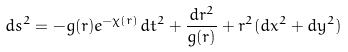Convert formula to latex. <formula><loc_0><loc_0><loc_500><loc_500>d s ^ { 2 } = - g ( r ) e ^ { - \chi ( r ) } d t ^ { 2 } + \frac { d r ^ { 2 } } { g ( r ) } + r ^ { 2 } ( d x ^ { 2 } + d y ^ { 2 } )</formula> 